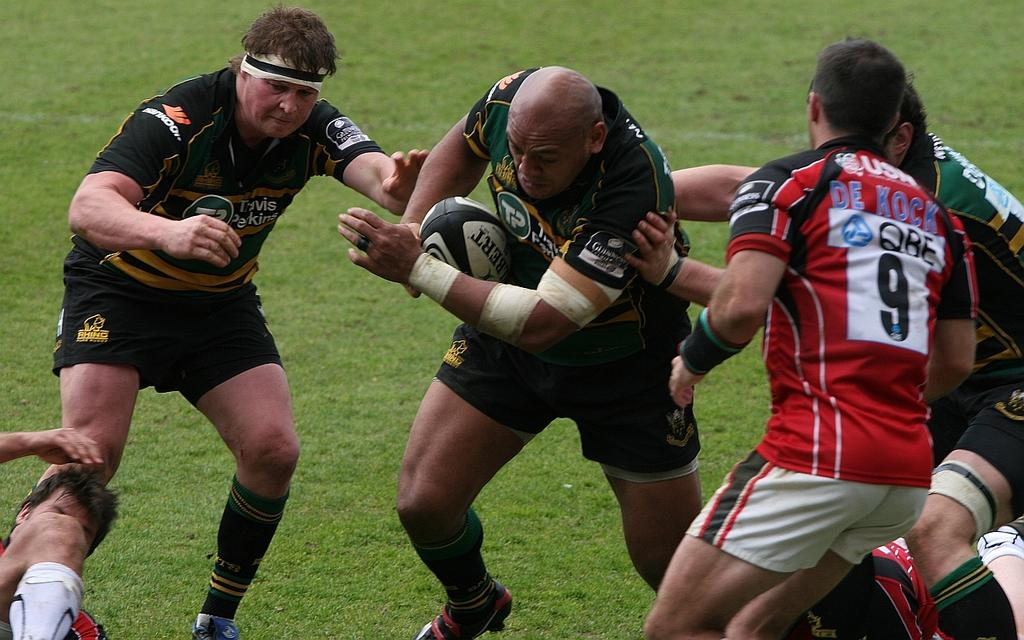How many people are in the image? There is a group of people in the image, but the exact number is not specified. What are the people in the image doing? The people are playing a game in the image. What object is involved in the game being played? There is a ball in the image. What type of surface is the game being played on? The ground in the image has grass. Can you see any spoons being used to stir a stream in the picture? There are no spoons or streams present in the image. The image features a group of people playing a game with a ball on a grassy surface. 